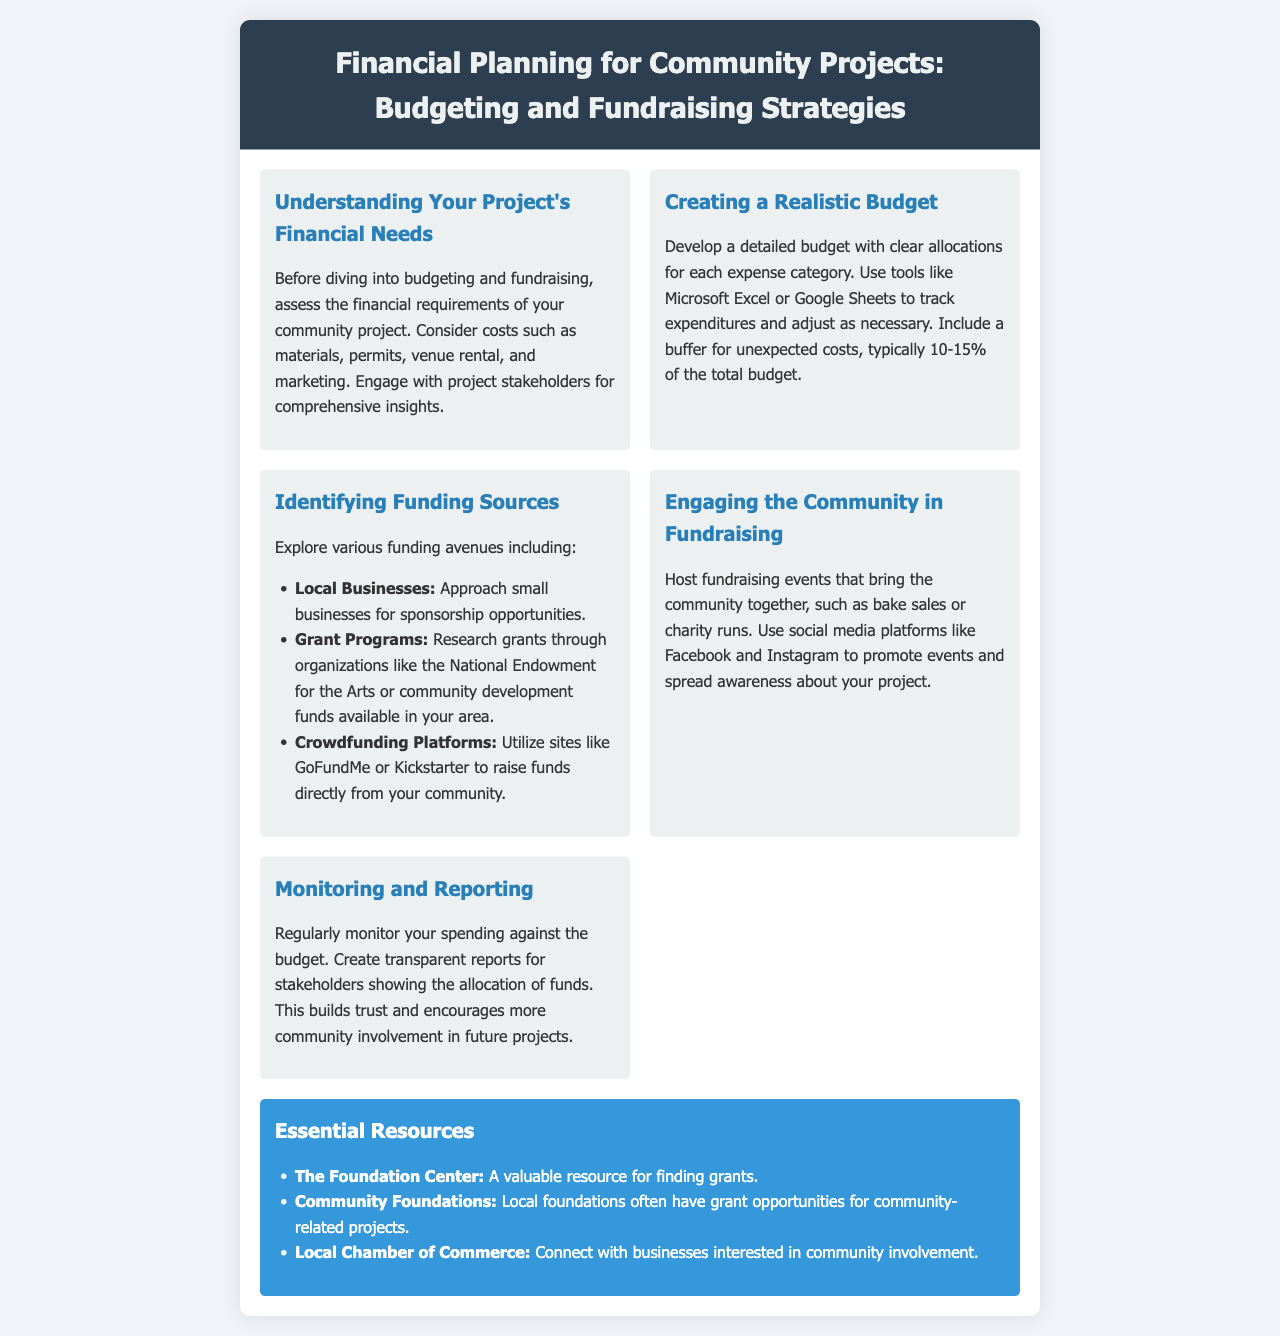What is the title of the brochure? The title appears in the header section of the document.
Answer: Financial Planning for Community Projects: Budgeting and Fundraising Strategies What is recommended for tracking expenditures? The section on budgeting suggests tools to keep track of spending.
Answer: Microsoft Excel or Google Sheets What percentage should be included as a buffer for unexpected costs? The budget section advises including a percentage for unexpected expenses.
Answer: 10-15% Which funding source involves local businesses? The section on funding sources includes a specific entry about local businesses.
Answer: Sponsorship opportunities What kind of fundraising events are suggested to engage the community? The engagement section provides examples of events that can involve community participation.
Answer: Bake sales or charity runs What should be created to build trust with stakeholders? The monitoring section emphasizes the importance of a certain type of report.
Answer: Transparent reports What type of resource is The Foundation Center? This part of the document discusses different resources related to grants.
Answer: A valuable resource for finding grants Which social media platforms are recommended for promoting events? The engagement section mentions specific platforms for raising awareness.
Answer: Facebook and Instagram What is the first step before budgeting and fundraising? The financial needs section highlights an initial action to take regarding project financing.
Answer: Assess the financial requirements 